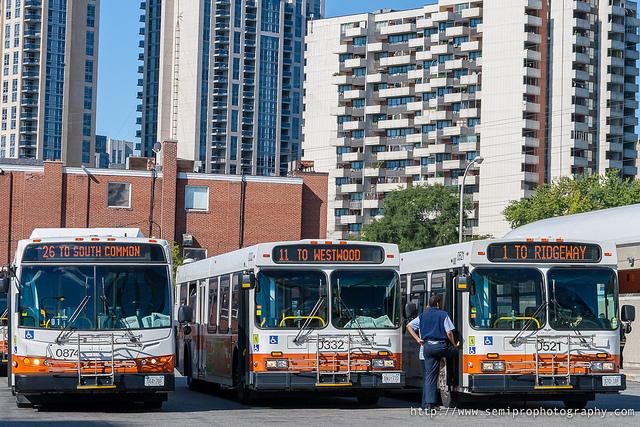How many buses are there?
Be succinct. 3. Where are the buses headed?
Write a very short answer. South common, westwood, ridgeway. Are the buses leaving soon?
Answer briefly. Yes. 